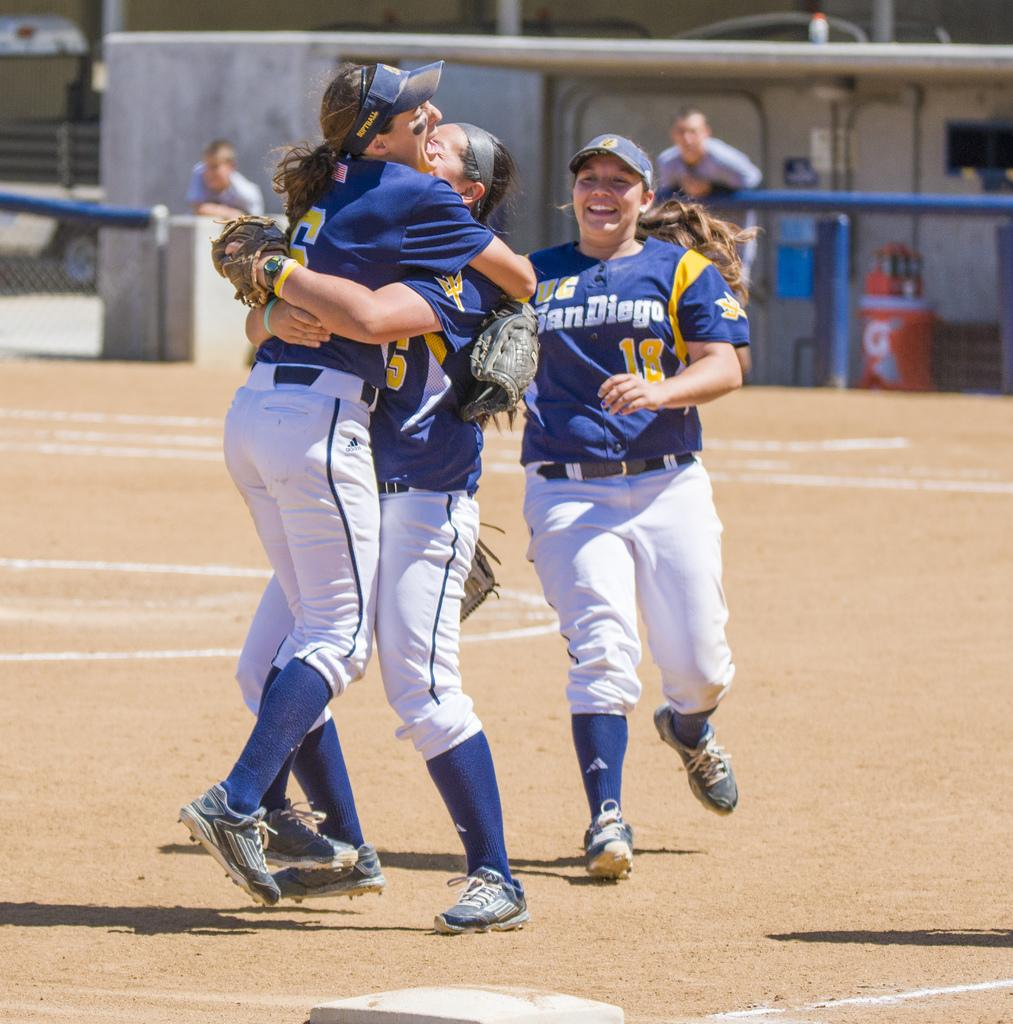<image>
Share a concise interpretation of the image provided. women from the UC San Diego ball league hug on the field 